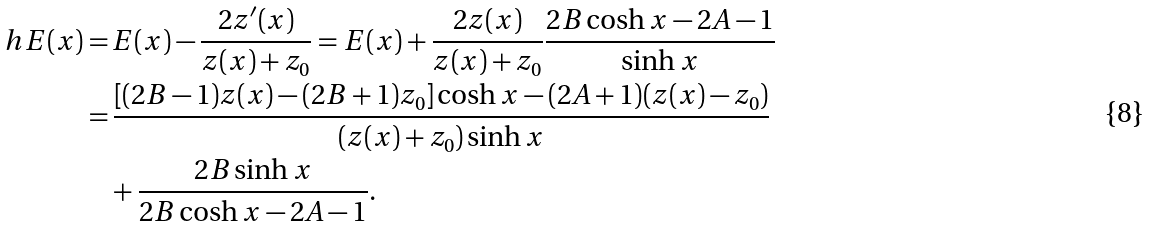<formula> <loc_0><loc_0><loc_500><loc_500>\ h E ( x ) = & \, E ( x ) - \frac { 2 z ^ { \prime } ( x ) } { z ( x ) + z _ { 0 } } = E ( x ) + \frac { 2 z ( x ) } { z ( x ) + z _ { 0 } } \frac { 2 B \cosh x - 2 A - 1 } { \sinh x } \\ = & \, \frac { [ ( 2 B - 1 ) z ( x ) - ( 2 B + 1 ) z _ { 0 } ] \cosh x - ( 2 A + 1 ) ( z ( x ) - z _ { 0 } ) } { ( z ( x ) + z _ { 0 } ) \sinh x } \\ & + \frac { 2 B \sinh x } { 2 B \cosh x - 2 A - 1 } .</formula> 